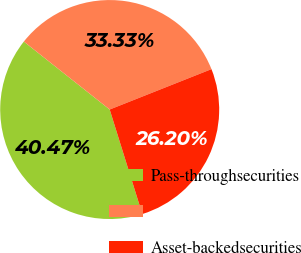Convert chart. <chart><loc_0><loc_0><loc_500><loc_500><pie_chart><fcel>Pass-throughsecurities<fcel>Unnamed: 1<fcel>Asset-backedsecurities<nl><fcel>40.47%<fcel>33.33%<fcel>26.2%<nl></chart> 